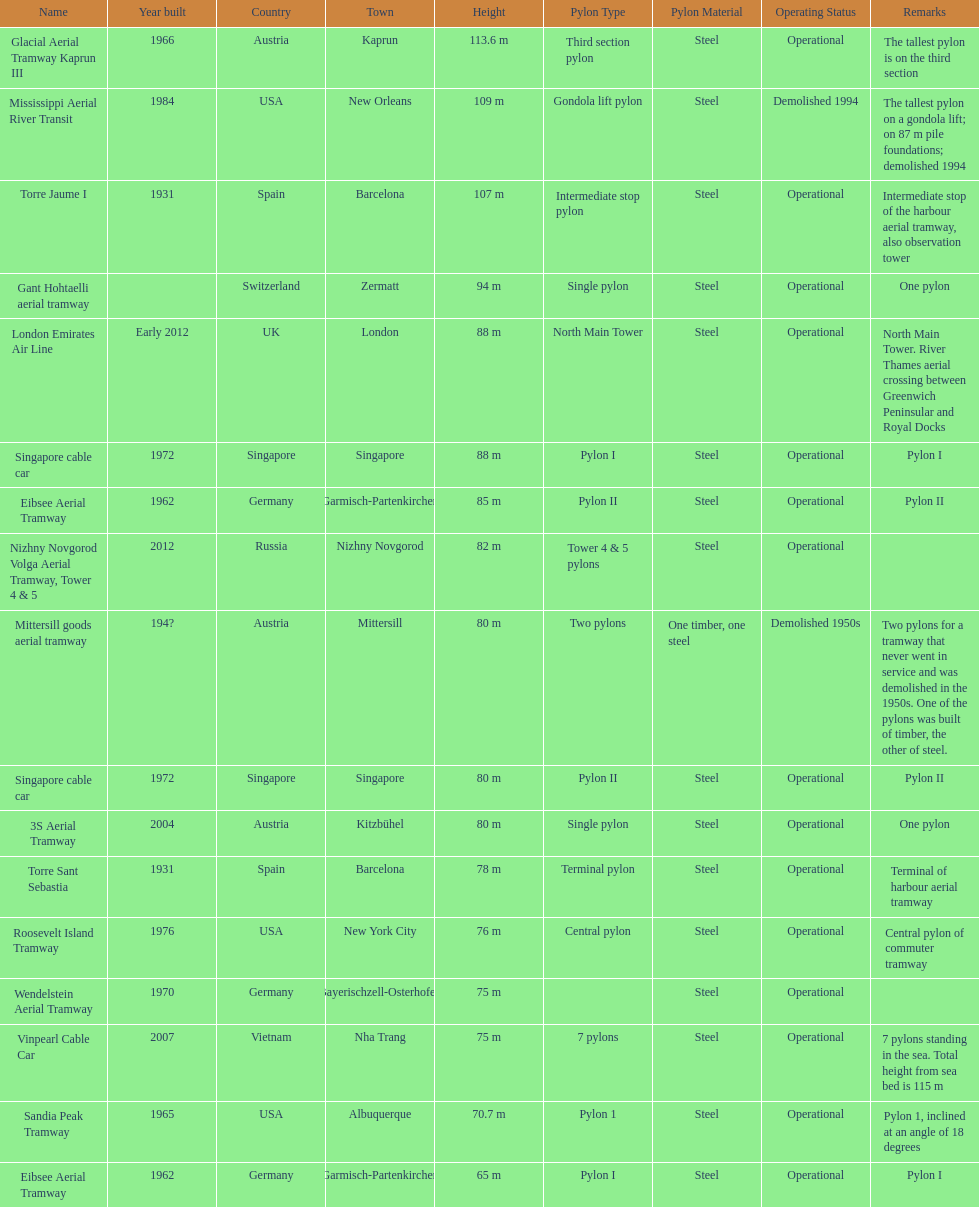Could you help me parse every detail presented in this table? {'header': ['Name', 'Year built', 'Country', 'Town', 'Height', 'Pylon Type', 'Pylon Material', 'Operating Status', 'Remarks'], 'rows': [['Glacial Aerial Tramway Kaprun III', '1966', 'Austria', 'Kaprun', '113.6 m', 'Third section pylon', 'Steel', 'Operational', 'The tallest pylon is on the third section'], ['Mississippi Aerial River Transit', '1984', 'USA', 'New Orleans', '109 m', 'Gondola lift pylon', 'Steel', 'Demolished 1994', 'The tallest pylon on a gondola lift; on 87 m pile foundations; demolished 1994'], ['Torre Jaume I', '1931', 'Spain', 'Barcelona', '107 m', 'Intermediate stop pylon', 'Steel', 'Operational', 'Intermediate stop of the harbour aerial tramway, also observation tower'], ['Gant Hohtaelli aerial tramway', '', 'Switzerland', 'Zermatt', '94 m', 'Single pylon', 'Steel', 'Operational', 'One pylon'], ['London Emirates Air Line', 'Early 2012', 'UK', 'London', '88 m', 'North Main Tower', 'Steel', 'Operational', 'North Main Tower. River Thames aerial crossing between Greenwich Peninsular and Royal Docks'], ['Singapore cable car', '1972', 'Singapore', 'Singapore', '88 m', 'Pylon I', 'Steel', 'Operational', 'Pylon I'], ['Eibsee Aerial Tramway', '1962', 'Germany', 'Garmisch-Partenkirchen', '85 m', 'Pylon II', 'Steel', 'Operational', 'Pylon II'], ['Nizhny Novgorod Volga Aerial Tramway, Tower 4 & 5', '2012', 'Russia', 'Nizhny Novgorod', '82 m', 'Tower 4 & 5 pylons', 'Steel', 'Operational', ''], ['Mittersill goods aerial tramway', '194?', 'Austria', 'Mittersill', '80 m', 'Two pylons', 'One timber, one steel', 'Demolished 1950s', 'Two pylons for a tramway that never went in service and was demolished in the 1950s. One of the pylons was built of timber, the other of steel.'], ['Singapore cable car', '1972', 'Singapore', 'Singapore', '80 m', 'Pylon II', 'Steel', 'Operational', 'Pylon II'], ['3S Aerial Tramway', '2004', 'Austria', 'Kitzbühel', '80 m', 'Single pylon', 'Steel', 'Operational', 'One pylon'], ['Torre Sant Sebastia', '1931', 'Spain', 'Barcelona', '78 m', 'Terminal pylon', 'Steel', 'Operational', 'Terminal of harbour aerial tramway'], ['Roosevelt Island Tramway', '1976', 'USA', 'New York City', '76 m', 'Central pylon', 'Steel', 'Operational', 'Central pylon of commuter tramway'], ['Wendelstein Aerial Tramway', '1970', 'Germany', 'Bayerischzell-Osterhofen', '75 m', '', 'Steel', 'Operational', ''], ['Vinpearl Cable Car', '2007', 'Vietnam', 'Nha Trang', '75 m', '7 pylons', 'Steel', 'Operational', '7 pylons standing in the sea. Total height from sea bed is 115 m'], ['Sandia Peak Tramway', '1965', 'USA', 'Albuquerque', '70.7 m', 'Pylon 1', 'Steel', 'Operational', 'Pylon 1, inclined at an angle of 18 degrees'], ['Eibsee Aerial Tramway', '1962', 'Germany', 'Garmisch-Partenkirchen', '65 m', 'Pylon I', 'Steel', 'Operational', 'Pylon I']]} What is the total number of pylons listed? 17. 